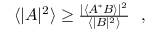<formula> <loc_0><loc_0><loc_500><loc_500>\begin{array} { r } { \langle | A | ^ { 2 } \rangle \geq \frac { | \langle A ^ { \ast } B \rangle | ^ { 2 } } { \langle | B | ^ { 2 } \rangle } , } \end{array}</formula> 